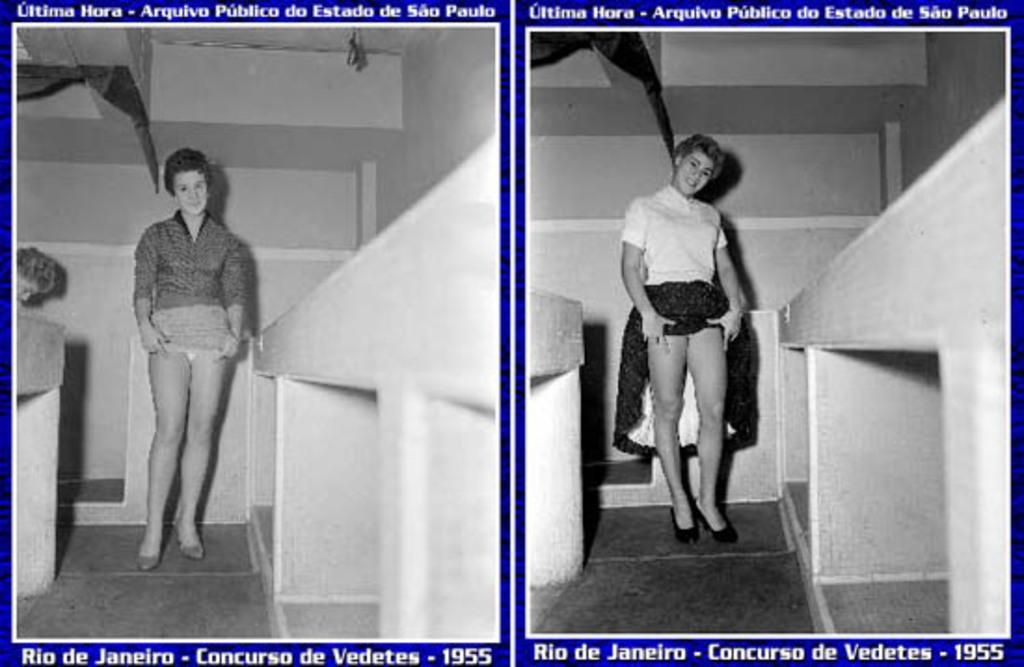What type of image is being described? The image is a collage. What can be seen in the collage? There are women standing in the image. Where are the women standing? The women are standing on the floor. What is present at the top and bottom of the collage? There is text at the top and bottom of the collage image. What type of plantation is visible in the image? There is no plantation present in the image; it is a collage featuring women standing on the floor with text at the top and bottom. 